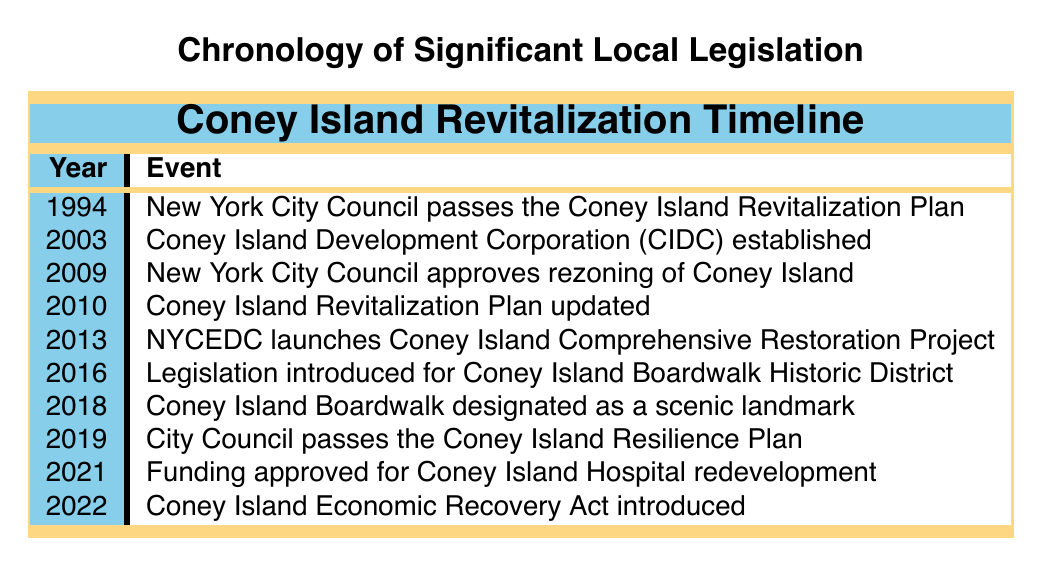What year did the New York City Council pass the Coney Island Revitalization Plan? The table shows that the New York City Council passed the Coney Island Revitalization Plan in the year 1994.
Answer: 1994 How many years passed between the establishment of the Coney Island Development Corporation and the rezoning approval? The Coney Island Development Corporation was established in 2003 and the rezoning was approved in 2009. The difference between 2009 and 2003 is 6 years.
Answer: 6 years Did the City Council pass the Coney Island Resilience Plan before or after the designation of the Coney Island Boardwalk as a scenic landmark? The Coney Island Resilience Plan was passed in 2019, and the Boardwalk was designated as a landmark in 2018. Since 2019 is after 2018, the Plan was passed after the designation.
Answer: After How many significant events related to Coney Island revitalization happened in the 21st century? From 2003 to 2022, there are 7 events listed in the table. They are from the years 2003, 2009, 2010, 2013, 2016, 2018, 2019, 2021, and 2022, which total 9 events.
Answer: 9 events Which year saw the launch of the Coney Island Comprehensive Restoration Project? According to the table, the NYCEDC launched the Coney Island Comprehensive Restoration Project in 2013.
Answer: 2013 What is the earliest event mentioned in the timeline? The earliest event is the passing of the Coney Island Revitalization Plan by the New York City Council in 1994.
Answer: Passing of the Revitalization Plan in 1994 Is the Coney Island Economic Recovery Act the last event listed in the timeline? The table indicates that the last event is the introduction of the Coney Island Economic Recovery Act in 2022, making it the last event listed.
Answer: Yes What was the focus of the updated Coney Island Revitalization Plan in 2010? The table states that the updated plan in 2010 focused on infrastructure improvements and new attractions.
Answer: Infrastructure improvements and new attractions In which year did the Coney Island Boardwalk become a scenic landmark? The table shows that the Coney Island Boardwalk was designated as a scenic landmark in 2018.
Answer: 2018 